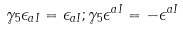<formula> <loc_0><loc_0><loc_500><loc_500>\gamma _ { 5 } \epsilon _ { a I } = \epsilon _ { a I } ; \gamma _ { 5 } \epsilon ^ { a I } = - \epsilon ^ { a I }</formula> 